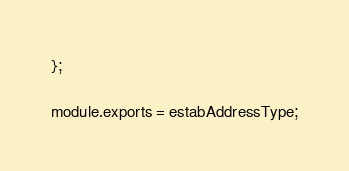<code> <loc_0><loc_0><loc_500><loc_500><_JavaScript_>};

module.exports = estabAddressType;
</code> 